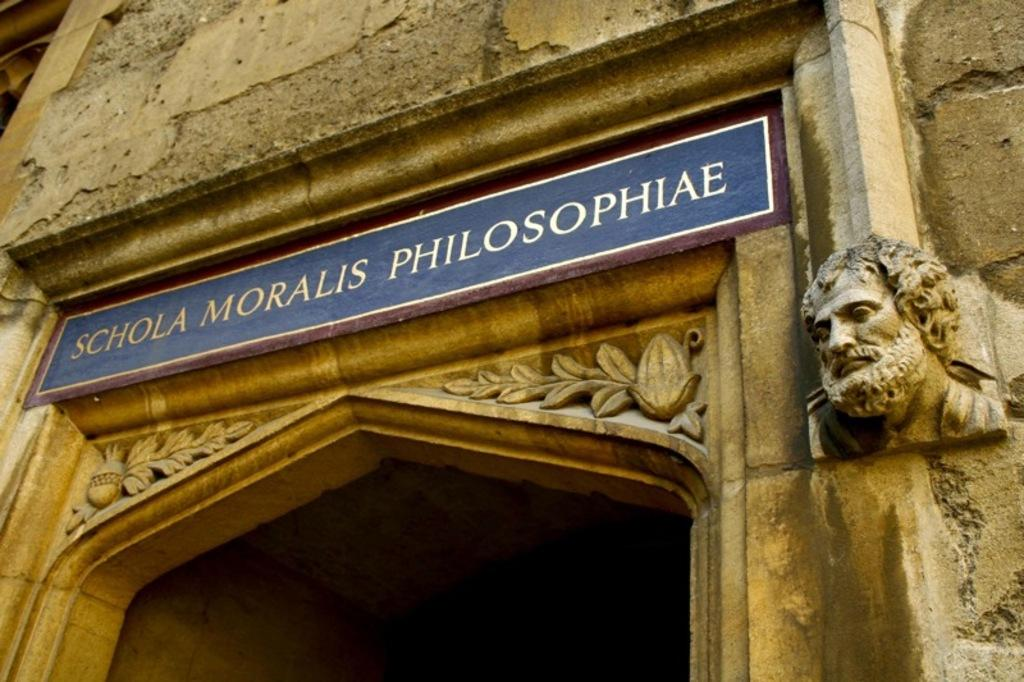What is the main structure in the image? There is a huge building in the image. What colors are used for the building? The building is brown and cream in color. What type of artwork is present in the image? There is a sculpture of a human head in the image. What is attached to the building and what color is it? There is a blue colored board attached to the building. How many ghosts can be seen interacting with the human head sculpture in the image? There are no ghosts present in the image; it only features a building, a sculpture of a human head, and a blue colored board. What type of shop is located inside the building in the image? There is no information about a shop inside the building in the image; it only shows the exterior of the building. 